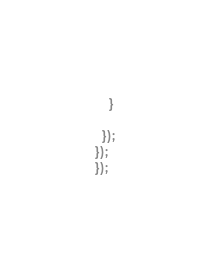Convert code to text. <code><loc_0><loc_0><loc_500><loc_500><_JavaScript_>    }

  });
});  
});</code> 